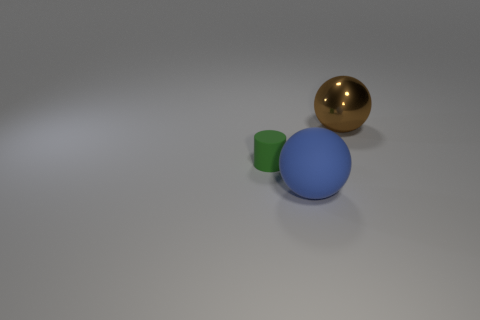What could be the possible materials the objects are made of based on their appearance? Based on their appearance, the green cylinder looks like it's made of a matte plastic material due to its opaque surface. The blue sphere seems to be of a similar matte plastic, and the gold sphere exhibits a reflective surface that suggests it could be a polished metal. 